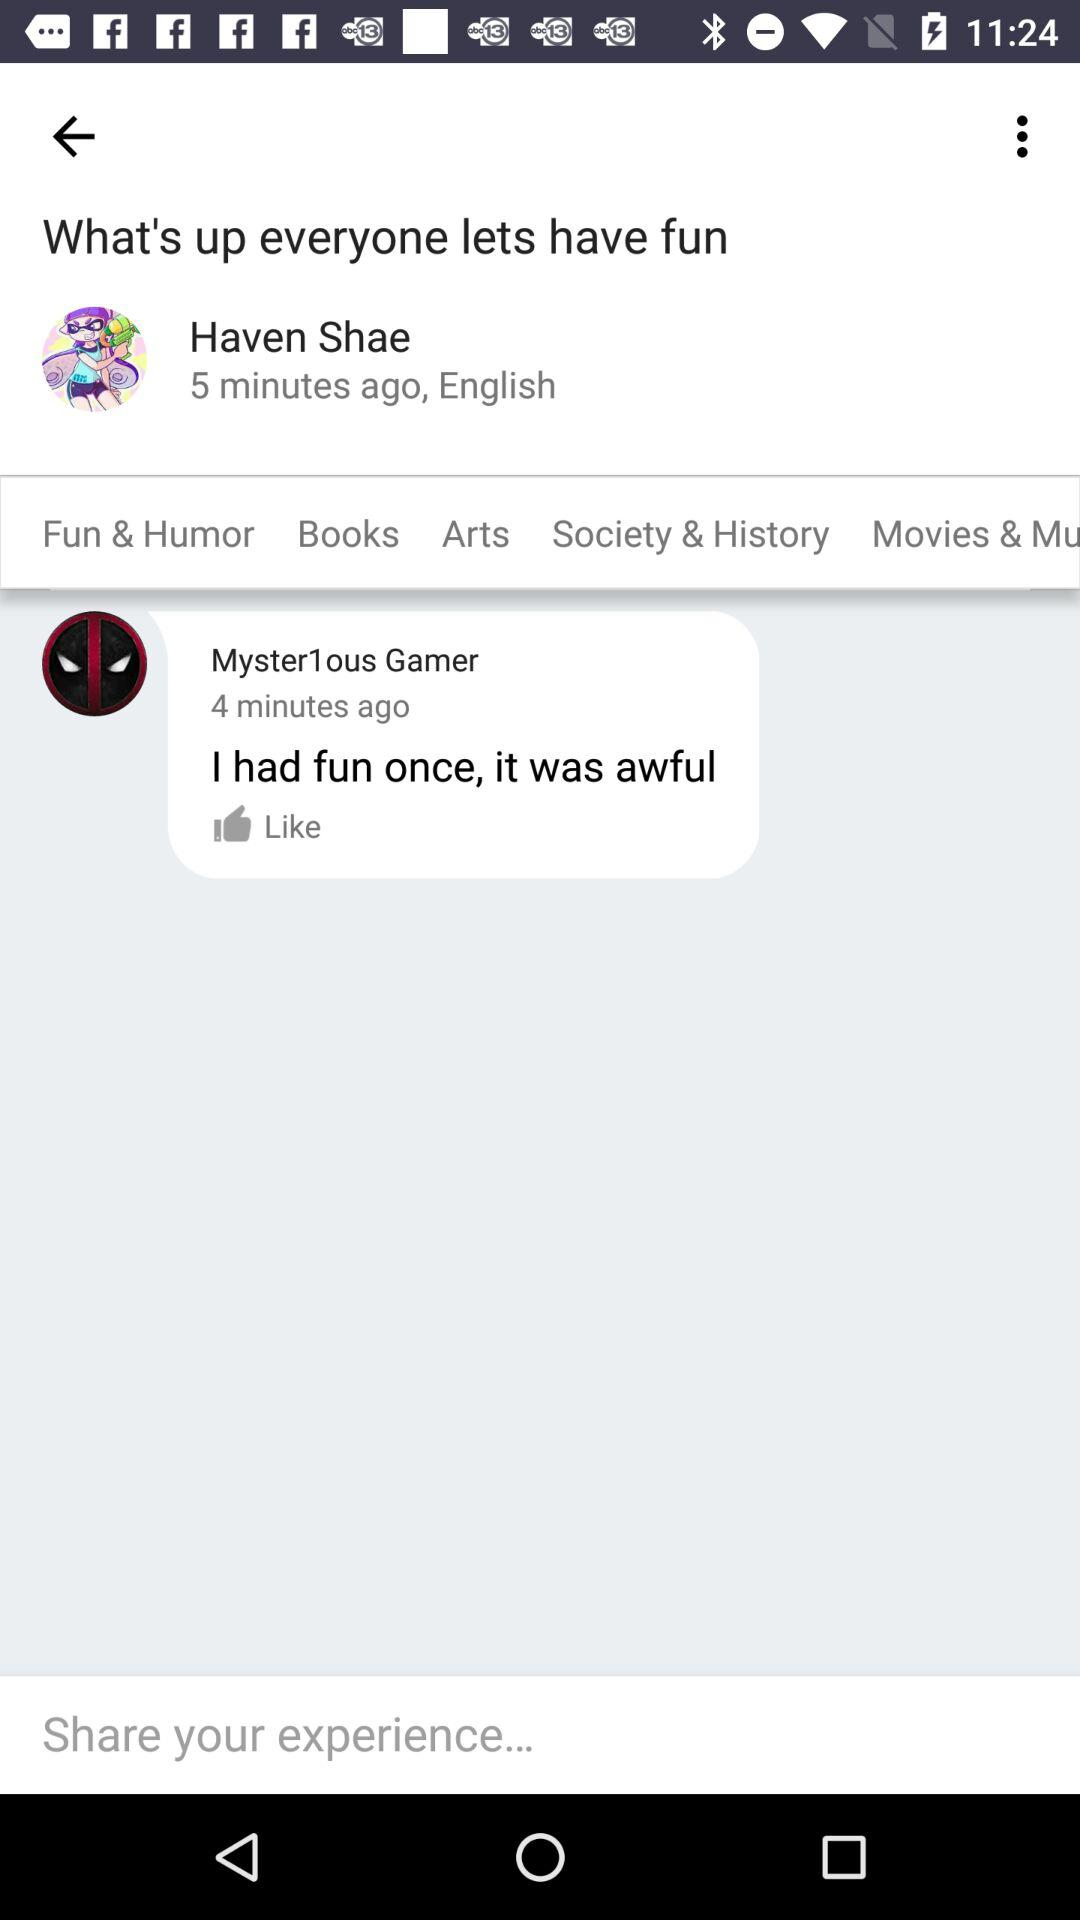How many more minutes ago did Haven Shae post than Mister1ous Gamer?
Answer the question using a single word or phrase. 1 